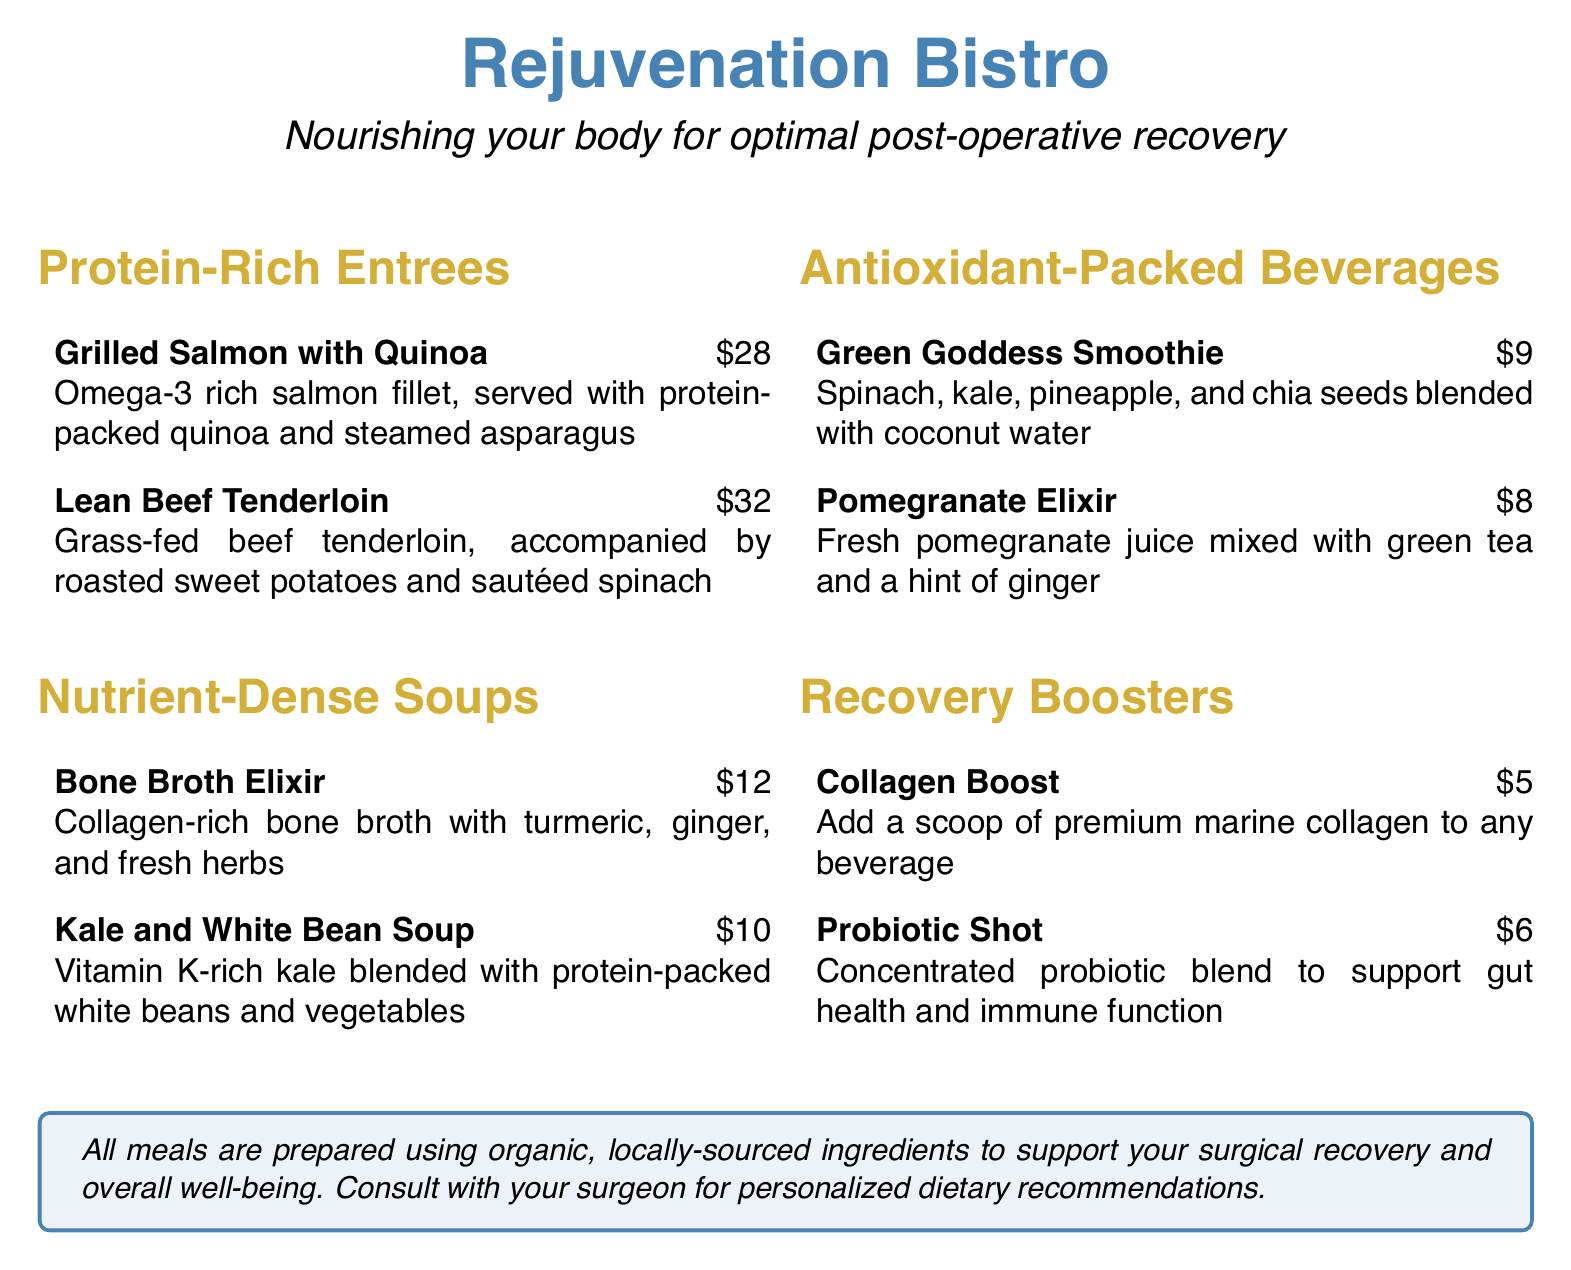What is the name of the restaurant? The name of the restaurant is prominently displayed at the top of the document.
Answer: Rejuvenation Bistro What type of meals does the restaurant offer? The document specifies that the meals are designed to complement post-operative care and recovery.
Answer: Nutrient-rich meals How much is the Grilled Salmon with Quinoa? The price for the Grilled Salmon with Quinoa is listed next to the dish.
Answer: $28 What is included in the Collagen Boost? The Collagen Boost is described in the Recovery Boosters section.
Answer: A scoop of premium marine collagen How much does a Probiotic Shot cost? The cost of a Probiotic Shot is clearly stated in the document.
Answer: $6 What ingredient is common in the Bone Broth Elixir? The Bone Broth Elixir is described with specific ingredients.
Answer: Collagen How many types of Antioxidant-Packed Beverages are listed? The Antioxidant-Packed Beverages section includes all items listed under it.
Answer: 2 Which dish is accompanied by roasted sweet potatoes? The dish details state its accompaniments clearly.
Answer: Lean Beef Tenderloin What does the restaurant emphasize about its ingredients? There is a note on the quality of ingredients used in meals in the document.
Answer: Organic, locally-sourced ingredients 